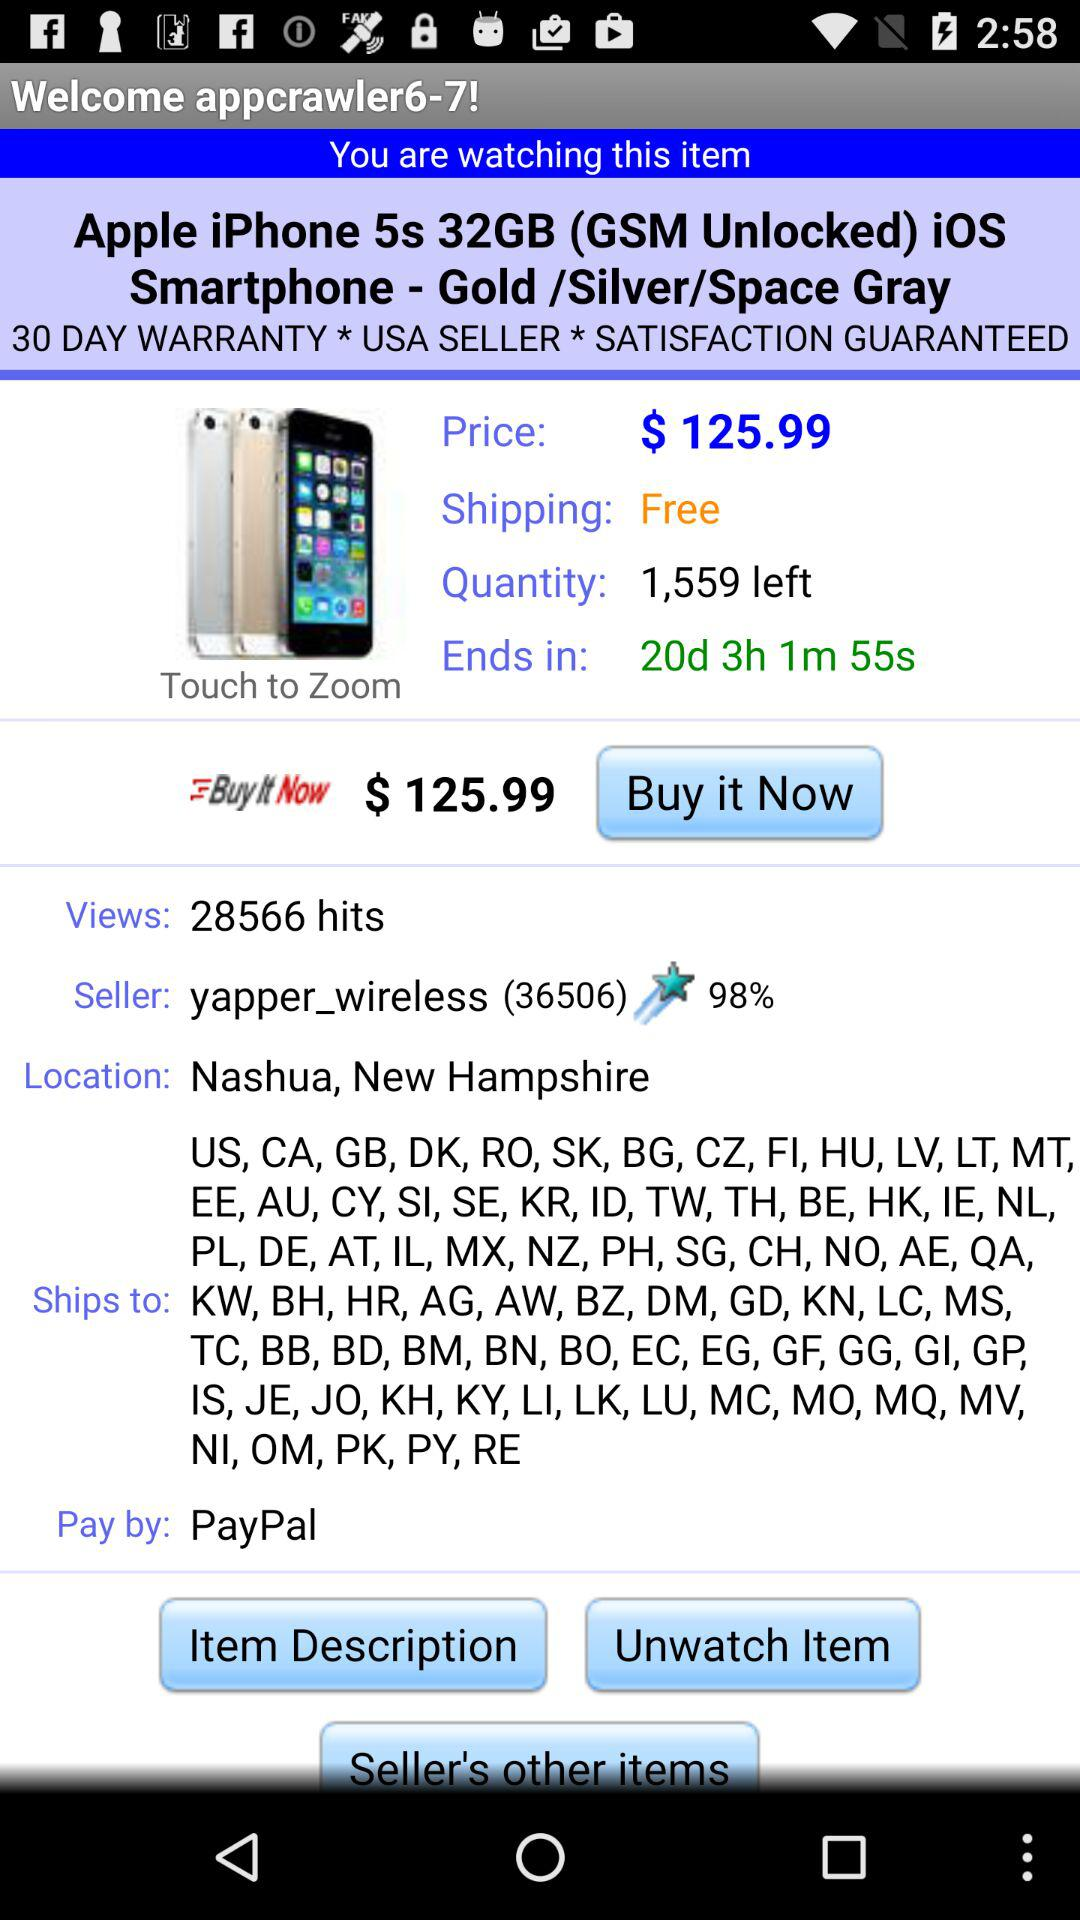What is the shipping charge? The shipping charge is free. 